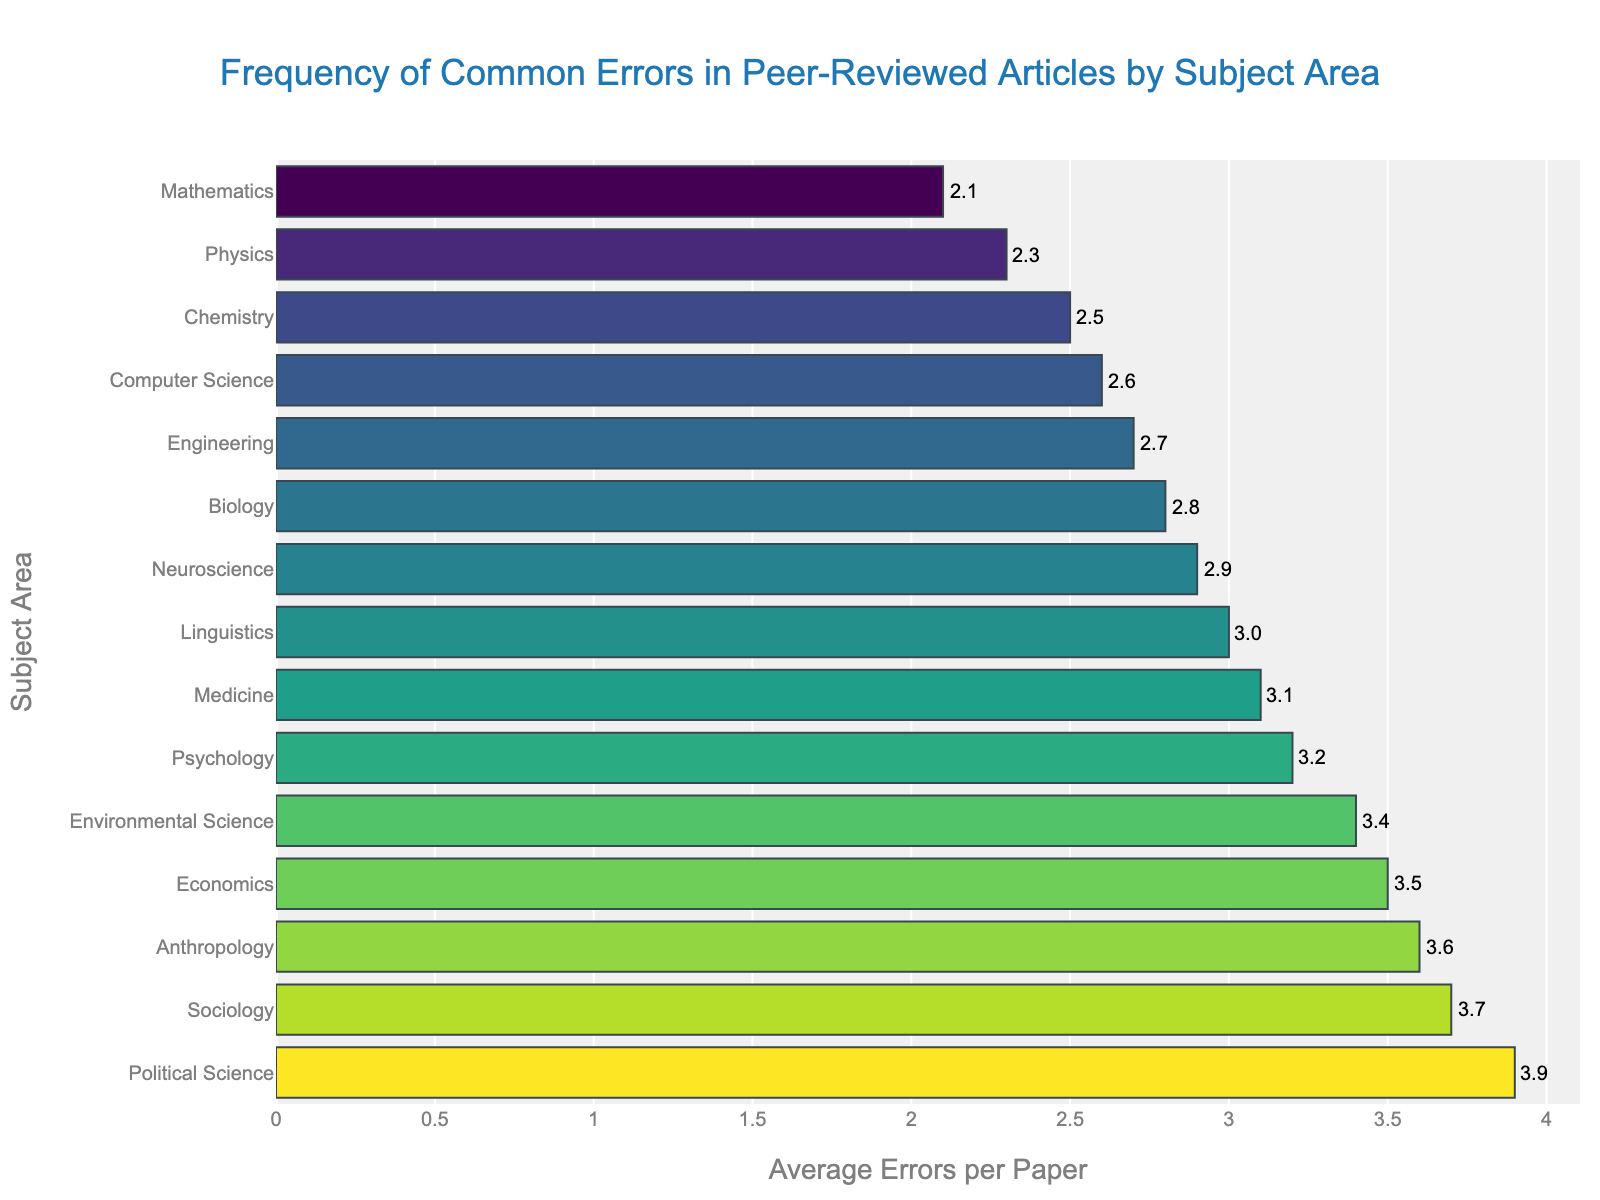Which subject area has the highest average errors per paper? The figure shows the average errors per paper for different subject areas. By looking at the horizontal bars, the longest bar corresponds to Political Science.
Answer: Political Science Which two subject areas have the lowest average errors per paper, and what are those averages? The two shortest bars in the figure represent Mathematics and Physics. The bar lengths and annotations indicate their averages.
Answer: Mathematics (2.1), Physics (2.3) How much higher is the average error rate in Sociology compared to Computer Science? Find the bars for Sociology and Computer Science. The average for Sociology is 3.7, and for Computer Science, it's 2.6. Subtract to find the difference.
Answer: 1.1 What is the average error rate for Psychology and Medicine combined? Find the bars and annotations for Psychology and Medicine. Add their averages together (3.2 + 3.1) and divide by 2 to find their combined average.
Answer: 3.15 Is the average error rate for Economics closer to that of Psychology or Environmental Science? Observe the averages for Economics (3.5), Psychology (3.2), and Environmental Science (3.4). Calculate the difference between Economics and the other two subject areas.
Answer: Environmental Science What is the range of average errors per paper across all subject areas shown in the figure? Identify the highest average (Political Science, 3.9) and the lowest average (Mathematics, 2.1) and subtract the lowest from the highest to find the range.
Answer: 1.8 Which subject area(s) has an average error rate between 2.5 and 3.0? Look at the bars within the specified range and identify the respective subjects.
Answer: Computer Science (2.6), Chemistry (2.5), Neuroscience (2.9), Linguistics (3.0) How does the average error rate in Anthropology compare to that in Sociology? Locate the bars for Anthropology (3.6) and Sociology (3.7). Compare their lengths to determine the difference.
Answer: Sociology is 0.1 higher What is the total sum of average errors per paper for Physics, Chemistry, and Engineering? Add the averages for the three subject areas: Physics (2.3), Chemistry (2.5), and Engineering (2.7) to find the total.
Answer: 7.5 If the average error rate for a new subject called "History" is 3.0, which existing subject area(s) have a similar error rate? Compare the proposed error rate for History to the existing subject areas to find similarity.
Answer: Linguistics (3.0) 